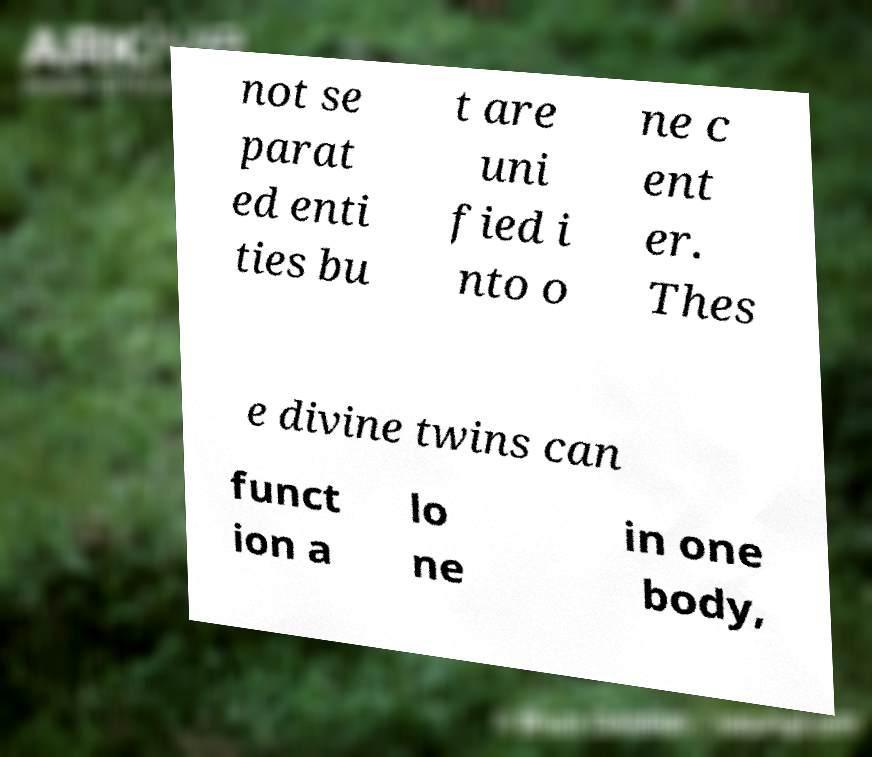Please identify and transcribe the text found in this image. not se parat ed enti ties bu t are uni fied i nto o ne c ent er. Thes e divine twins can funct ion a lo ne in one body, 